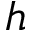Convert formula to latex. <formula><loc_0><loc_0><loc_500><loc_500>h</formula> 